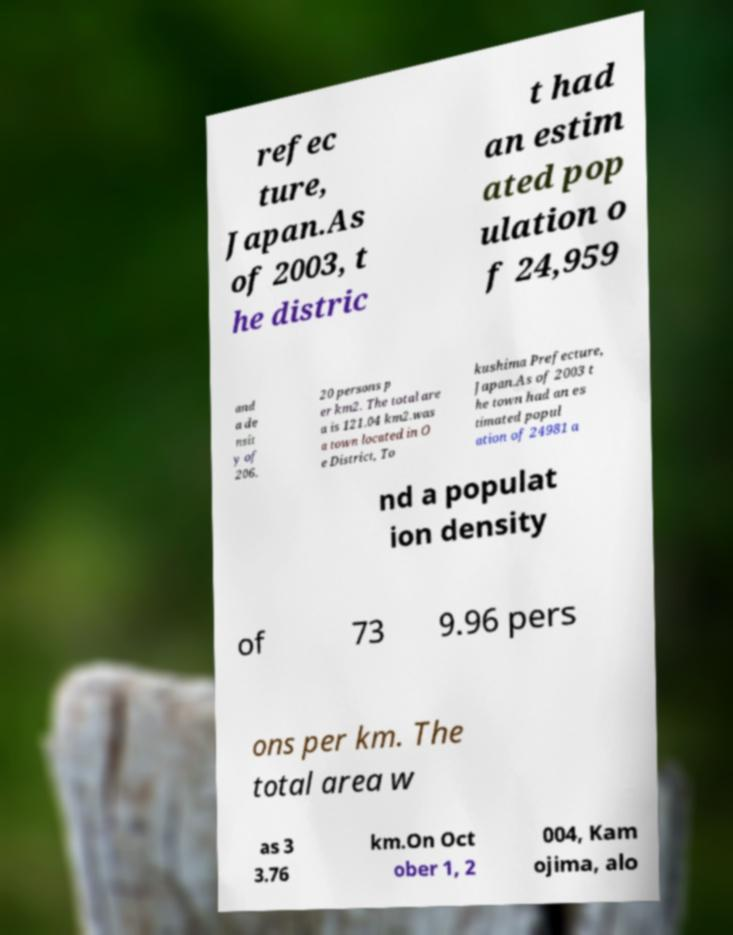Could you extract and type out the text from this image? refec ture, Japan.As of 2003, t he distric t had an estim ated pop ulation o f 24,959 and a de nsit y of 206. 20 persons p er km2. The total are a is 121.04 km2.was a town located in O e District, To kushima Prefecture, Japan.As of 2003 t he town had an es timated popul ation of 24981 a nd a populat ion density of 73 9.96 pers ons per km. The total area w as 3 3.76 km.On Oct ober 1, 2 004, Kam ojima, alo 